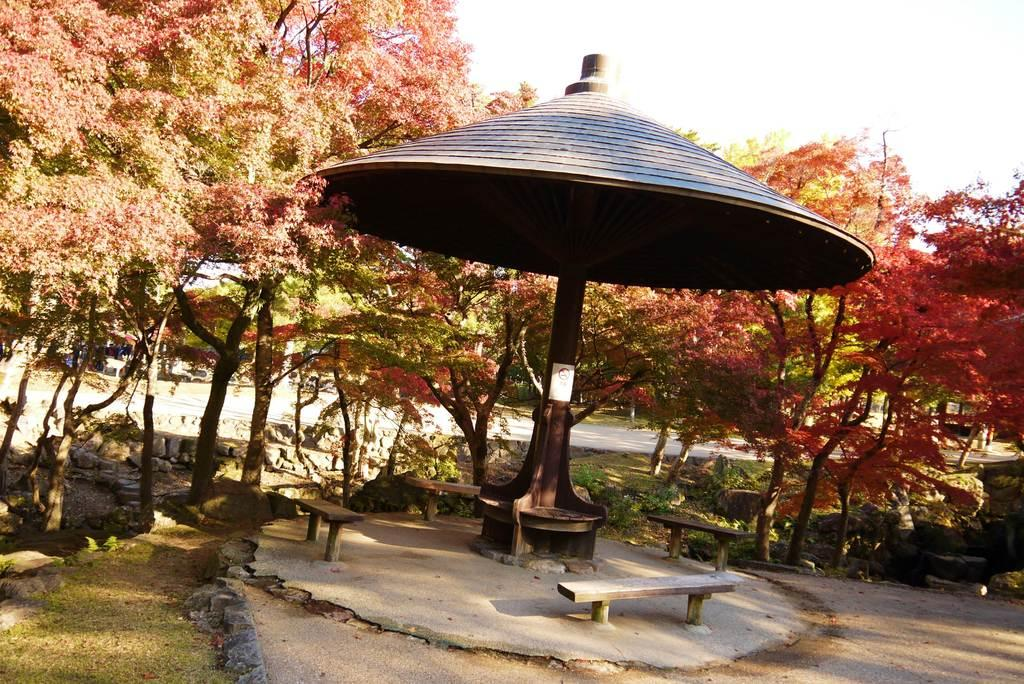What type of seating is visible in the image? There are benches in the image. Where are the benches located? The benches are placed under a roof. What can be seen in the background of the image? There is a group of trees and stones in the background of the image. What part of the natural environment is visible in the image? The sky is visible in the background of the image. How many clams are sitting on the benches in the image? There are no clams present in the image; the benches are meant for people to sit on. 